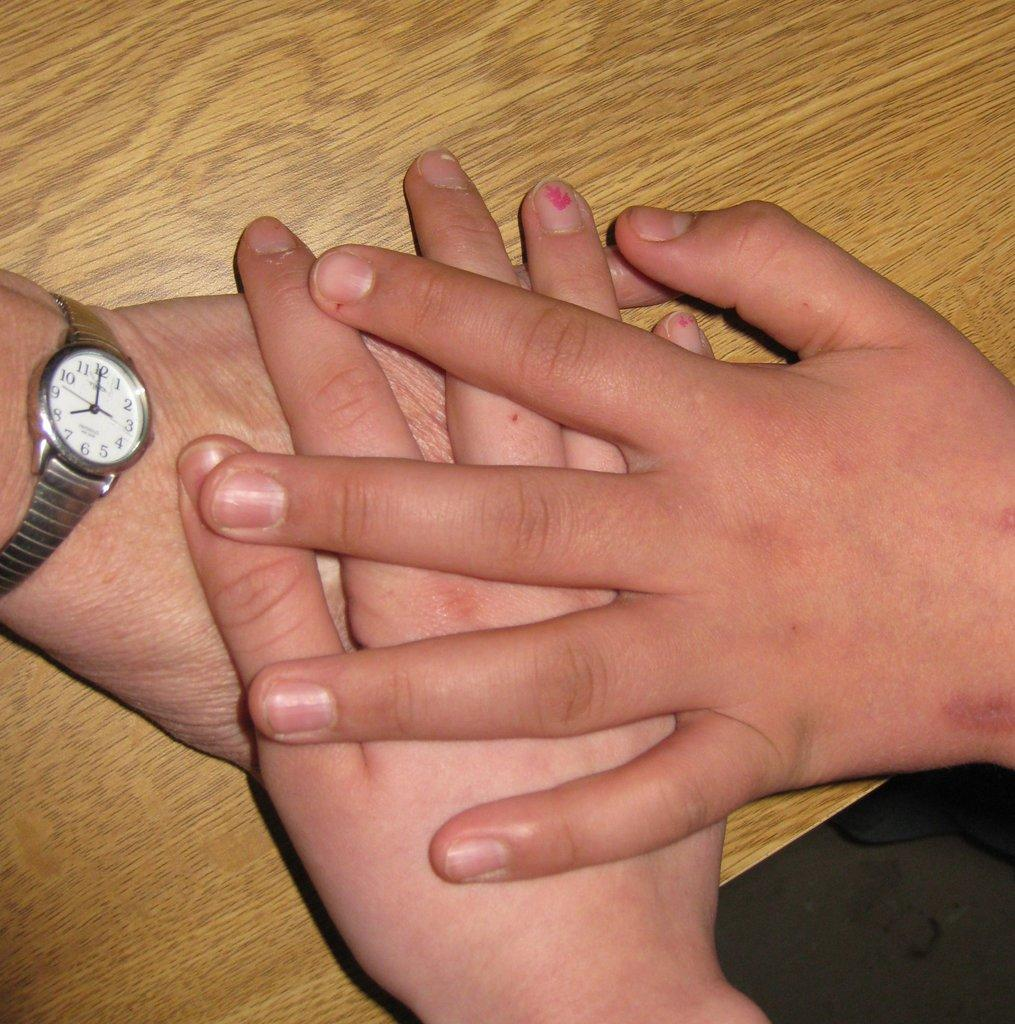<image>
Provide a brief description of the given image. Several different hands laying on a table stacked on top of each other with a Timex watch reading 8:00 on one wrist. 